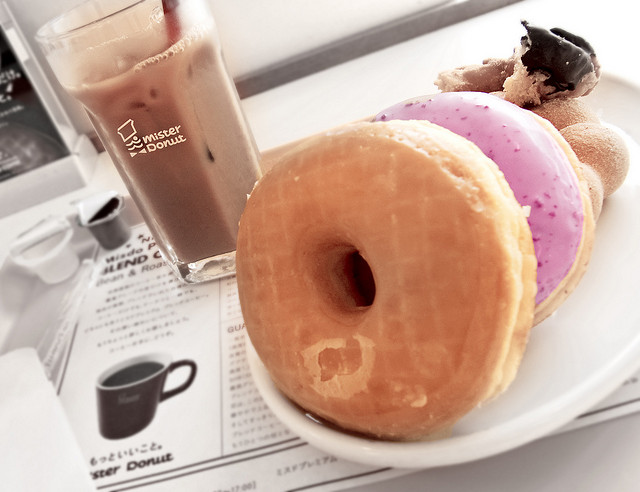What type of beverage is shown in the image? The beverage is an iced coffee, served in a tall glass with a straw, perfect for a refreshing sip on a warm day. What makes you think it's coffee? The deep brown color of the liquid and the presence of ice cubes suggest that it is iced coffee, which is a common companion to sweet treats like donuts. 